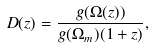<formula> <loc_0><loc_0><loc_500><loc_500>D ( z ) = \frac { g ( \Omega ( z ) ) } { g ( \Omega _ { m } ) ( 1 + z ) } ,</formula> 